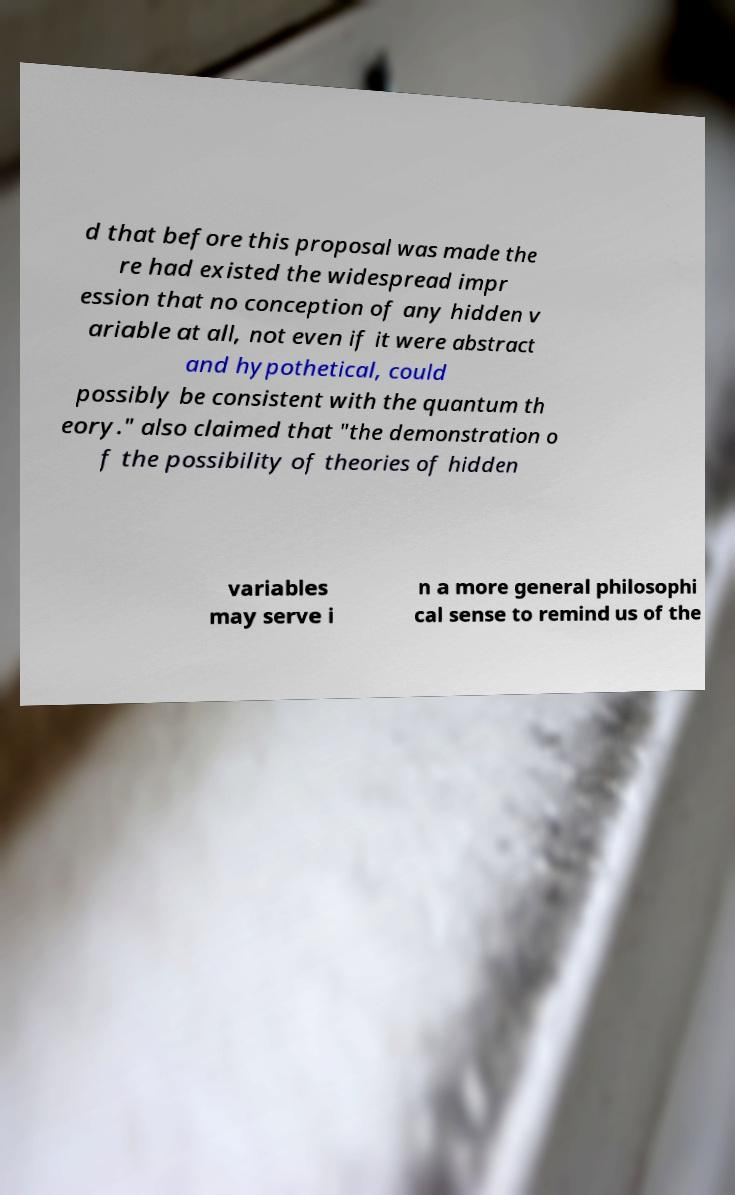For documentation purposes, I need the text within this image transcribed. Could you provide that? d that before this proposal was made the re had existed the widespread impr ession that no conception of any hidden v ariable at all, not even if it were abstract and hypothetical, could possibly be consistent with the quantum th eory." also claimed that "the demonstration o f the possibility of theories of hidden variables may serve i n a more general philosophi cal sense to remind us of the 